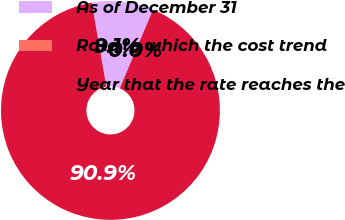Convert chart to OTSL. <chart><loc_0><loc_0><loc_500><loc_500><pie_chart><fcel>As of December 31<fcel>Rate to which the cost trend<fcel>Year that the rate reaches the<nl><fcel>9.09%<fcel>0.0%<fcel>90.91%<nl></chart> 